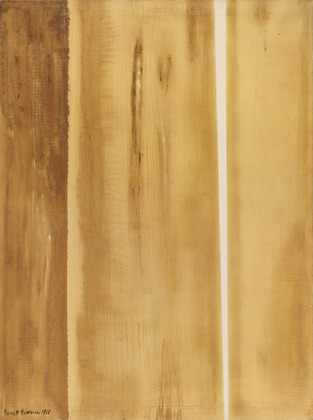Can you describe the main features of this image for me? The image presents an abstract art piece by Barnett Newman. It prominently displays vertical lines in varying shades of brown and beige tones. These shades create an impression of depth and texture, contributing to the rough appearance of the lines which are not uniform. This uneven texture combined with the warm, earthy color palette evokes a very tactile and visceral experience. The art style is known as abstract expressionism—a movement where spontaneity and subconscious creation are essential. More specifically, this painting falls under the genre of color field painting, which is characterized by large, solid areas of a single color. Despite its apparent simplicity, the painting invites a variety of emotional responses and interpretations, highlighting the evocative nature of abstract art. 